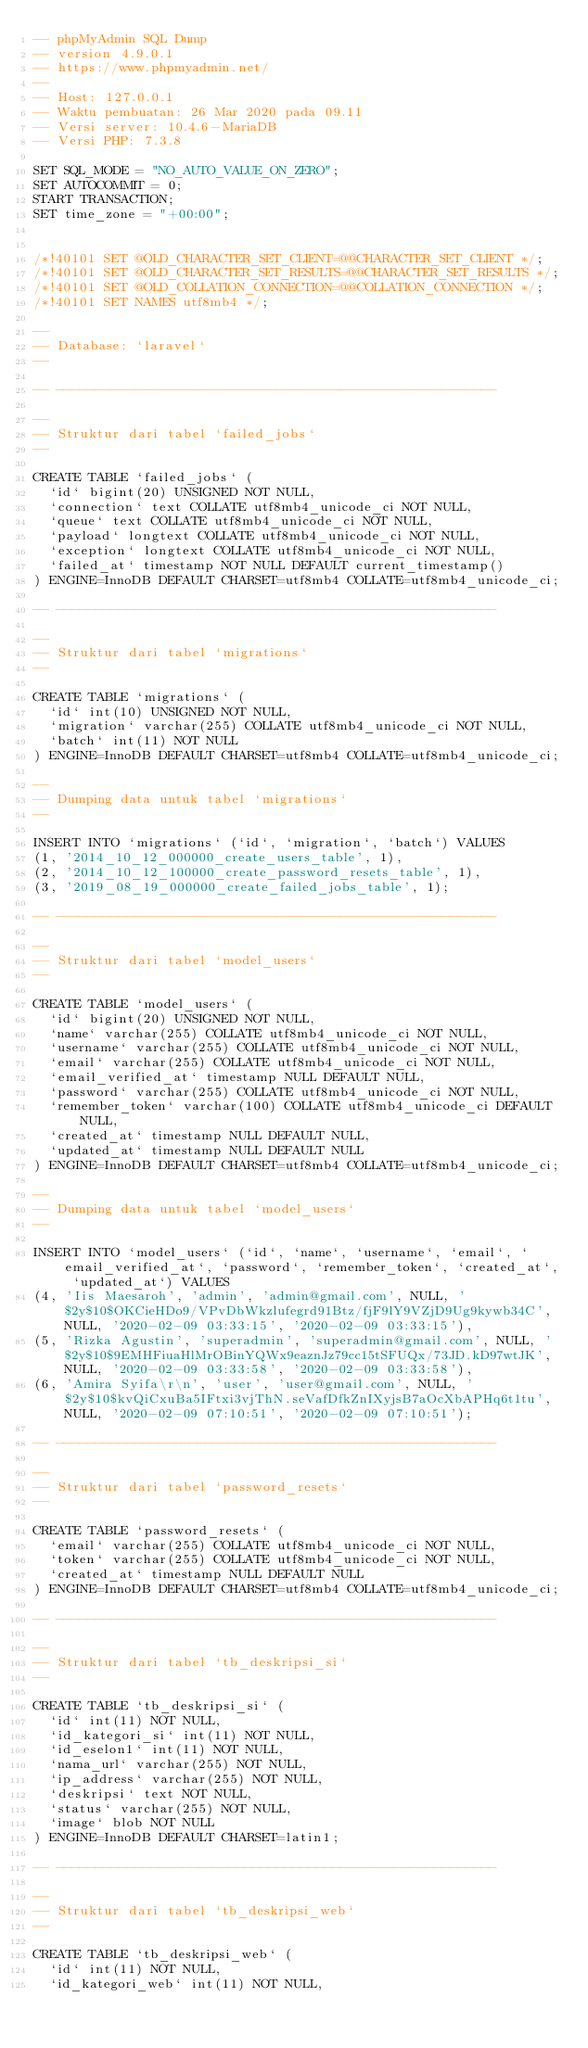Convert code to text. <code><loc_0><loc_0><loc_500><loc_500><_SQL_>-- phpMyAdmin SQL Dump
-- version 4.9.0.1
-- https://www.phpmyadmin.net/
--
-- Host: 127.0.0.1
-- Waktu pembuatan: 26 Mar 2020 pada 09.11
-- Versi server: 10.4.6-MariaDB
-- Versi PHP: 7.3.8

SET SQL_MODE = "NO_AUTO_VALUE_ON_ZERO";
SET AUTOCOMMIT = 0;
START TRANSACTION;
SET time_zone = "+00:00";


/*!40101 SET @OLD_CHARACTER_SET_CLIENT=@@CHARACTER_SET_CLIENT */;
/*!40101 SET @OLD_CHARACTER_SET_RESULTS=@@CHARACTER_SET_RESULTS */;
/*!40101 SET @OLD_COLLATION_CONNECTION=@@COLLATION_CONNECTION */;
/*!40101 SET NAMES utf8mb4 */;

--
-- Database: `laravel`
--

-- --------------------------------------------------------

--
-- Struktur dari tabel `failed_jobs`
--

CREATE TABLE `failed_jobs` (
  `id` bigint(20) UNSIGNED NOT NULL,
  `connection` text COLLATE utf8mb4_unicode_ci NOT NULL,
  `queue` text COLLATE utf8mb4_unicode_ci NOT NULL,
  `payload` longtext COLLATE utf8mb4_unicode_ci NOT NULL,
  `exception` longtext COLLATE utf8mb4_unicode_ci NOT NULL,
  `failed_at` timestamp NOT NULL DEFAULT current_timestamp()
) ENGINE=InnoDB DEFAULT CHARSET=utf8mb4 COLLATE=utf8mb4_unicode_ci;

-- --------------------------------------------------------

--
-- Struktur dari tabel `migrations`
--

CREATE TABLE `migrations` (
  `id` int(10) UNSIGNED NOT NULL,
  `migration` varchar(255) COLLATE utf8mb4_unicode_ci NOT NULL,
  `batch` int(11) NOT NULL
) ENGINE=InnoDB DEFAULT CHARSET=utf8mb4 COLLATE=utf8mb4_unicode_ci;

--
-- Dumping data untuk tabel `migrations`
--

INSERT INTO `migrations` (`id`, `migration`, `batch`) VALUES
(1, '2014_10_12_000000_create_users_table', 1),
(2, '2014_10_12_100000_create_password_resets_table', 1),
(3, '2019_08_19_000000_create_failed_jobs_table', 1);

-- --------------------------------------------------------

--
-- Struktur dari tabel `model_users`
--

CREATE TABLE `model_users` (
  `id` bigint(20) UNSIGNED NOT NULL,
  `name` varchar(255) COLLATE utf8mb4_unicode_ci NOT NULL,
  `username` varchar(255) COLLATE utf8mb4_unicode_ci NOT NULL,
  `email` varchar(255) COLLATE utf8mb4_unicode_ci NOT NULL,
  `email_verified_at` timestamp NULL DEFAULT NULL,
  `password` varchar(255) COLLATE utf8mb4_unicode_ci NOT NULL,
  `remember_token` varchar(100) COLLATE utf8mb4_unicode_ci DEFAULT NULL,
  `created_at` timestamp NULL DEFAULT NULL,
  `updated_at` timestamp NULL DEFAULT NULL
) ENGINE=InnoDB DEFAULT CHARSET=utf8mb4 COLLATE=utf8mb4_unicode_ci;

--
-- Dumping data untuk tabel `model_users`
--

INSERT INTO `model_users` (`id`, `name`, `username`, `email`, `email_verified_at`, `password`, `remember_token`, `created_at`, `updated_at`) VALUES
(4, 'Iis Maesaroh', 'admin', 'admin@gmail.com', NULL, '$2y$10$OKCieHDo9/VPvDbWkzlufegrd91Btz/fjF9lY9VZjD9Ug9kywb34C', NULL, '2020-02-09 03:33:15', '2020-02-09 03:33:15'),
(5, 'Rizka Agustin', 'superadmin', 'superadmin@gmail.com', NULL, '$2y$10$9EMHFiuaHlMrOBinYQWx9eaznJz79cc15tSFUQx/73JD.kD97wtJK', NULL, '2020-02-09 03:33:58', '2020-02-09 03:33:58'),
(6, 'Amira Syifa\r\n', 'user', 'user@gmail.com', NULL, '$2y$10$kvQiCxuBa5IFtxi3vjThN.seVafDfkZnIXyjsB7aOcXbAPHq6t1tu', NULL, '2020-02-09 07:10:51', '2020-02-09 07:10:51');

-- --------------------------------------------------------

--
-- Struktur dari tabel `password_resets`
--

CREATE TABLE `password_resets` (
  `email` varchar(255) COLLATE utf8mb4_unicode_ci NOT NULL,
  `token` varchar(255) COLLATE utf8mb4_unicode_ci NOT NULL,
  `created_at` timestamp NULL DEFAULT NULL
) ENGINE=InnoDB DEFAULT CHARSET=utf8mb4 COLLATE=utf8mb4_unicode_ci;

-- --------------------------------------------------------

--
-- Struktur dari tabel `tb_deskripsi_si`
--

CREATE TABLE `tb_deskripsi_si` (
  `id` int(11) NOT NULL,
  `id_kategori_si` int(11) NOT NULL,
  `id_eselon1` int(11) NOT NULL,
  `nama_url` varchar(255) NOT NULL,
  `ip_address` varchar(255) NOT NULL,
  `deskripsi` text NOT NULL,
  `status` varchar(255) NOT NULL,
  `image` blob NOT NULL
) ENGINE=InnoDB DEFAULT CHARSET=latin1;

-- --------------------------------------------------------

--
-- Struktur dari tabel `tb_deskripsi_web`
--

CREATE TABLE `tb_deskripsi_web` (
  `id` int(11) NOT NULL,
  `id_kategori_web` int(11) NOT NULL,</code> 